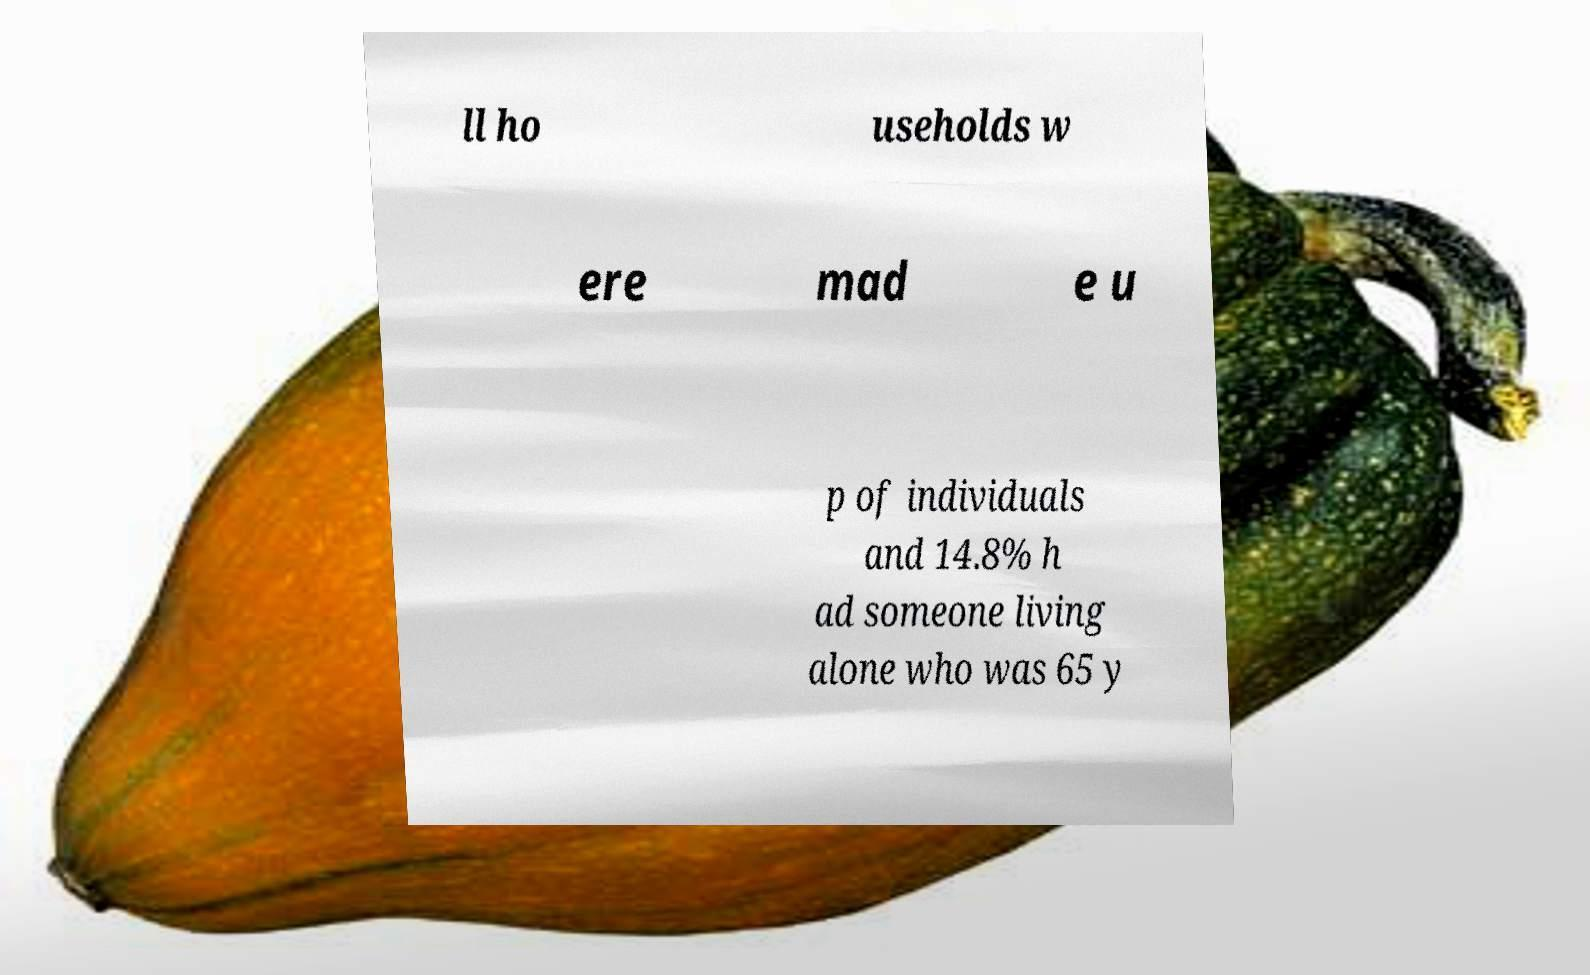There's text embedded in this image that I need extracted. Can you transcribe it verbatim? ll ho useholds w ere mad e u p of individuals and 14.8% h ad someone living alone who was 65 y 